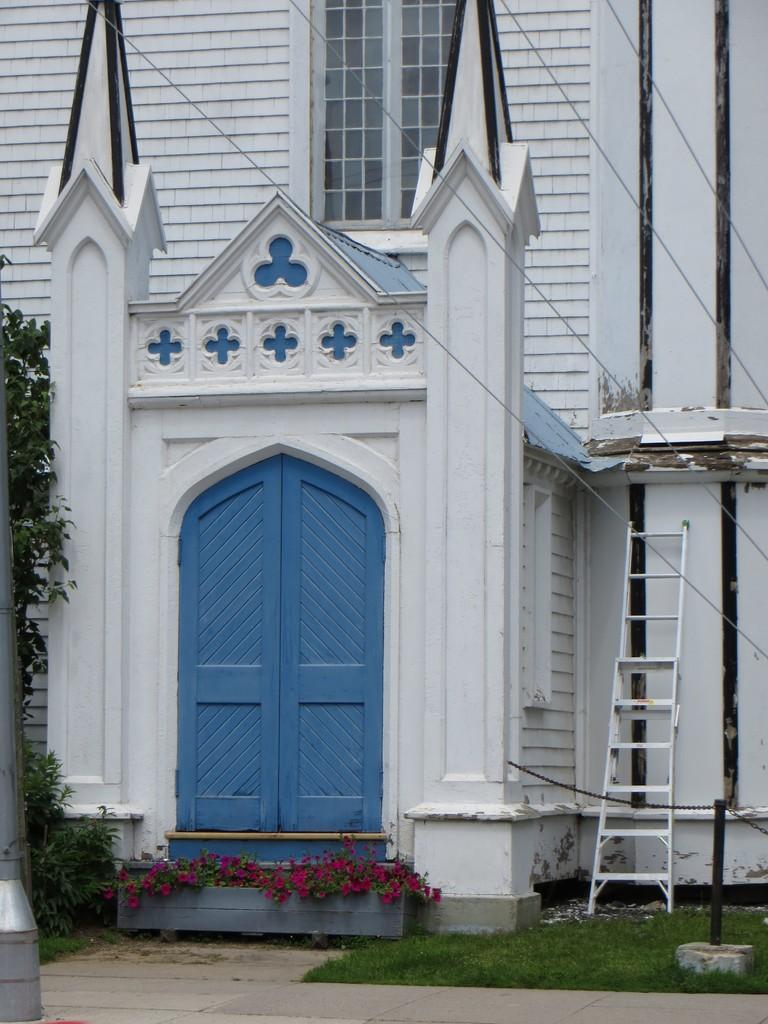Could you give a brief overview of what you see in this image? In this image we can see there is a building and a potted plant. At the side there is a ladder, pole, trees and grass. 